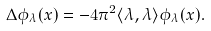Convert formula to latex. <formula><loc_0><loc_0><loc_500><loc_500>\Delta \phi _ { \lambda } ( x ) = - 4 \pi ^ { 2 } \langle \lambda , \lambda \rangle \phi _ { \lambda } ( x ) .</formula> 